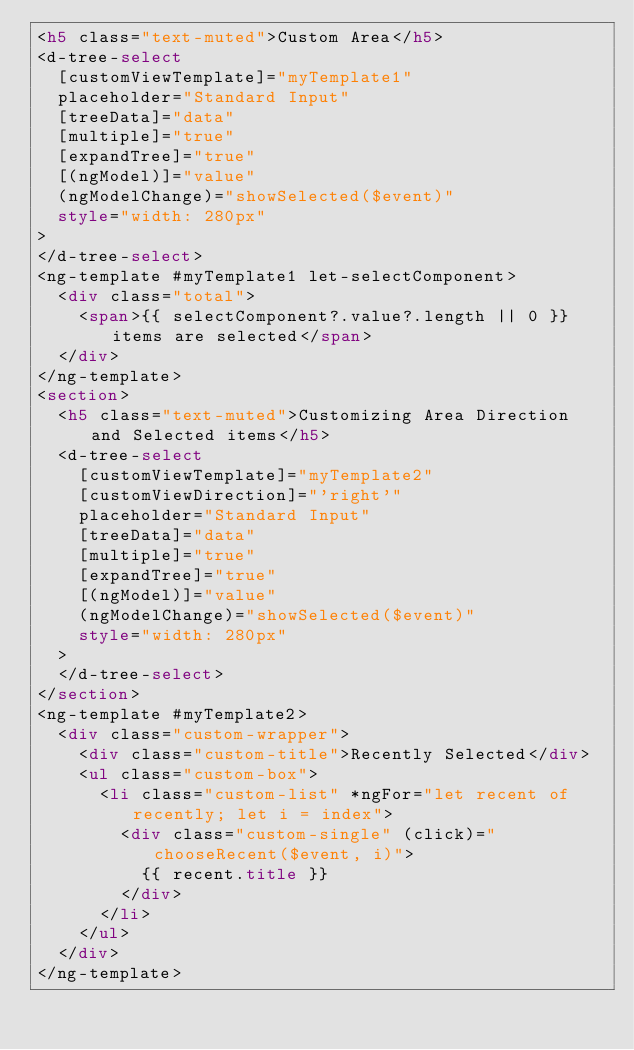<code> <loc_0><loc_0><loc_500><loc_500><_HTML_><h5 class="text-muted">Custom Area</h5>
<d-tree-select
  [customViewTemplate]="myTemplate1"
  placeholder="Standard Input"
  [treeData]="data"
  [multiple]="true"
  [expandTree]="true"
  [(ngModel)]="value"
  (ngModelChange)="showSelected($event)"
  style="width: 280px"
>
</d-tree-select>
<ng-template #myTemplate1 let-selectComponent>
  <div class="total">
    <span>{{ selectComponent?.value?.length || 0 }} items are selected</span>
  </div>
</ng-template>
<section>
  <h5 class="text-muted">Customizing Area Direction and Selected items</h5>
  <d-tree-select
    [customViewTemplate]="myTemplate2"
    [customViewDirection]="'right'"
    placeholder="Standard Input"
    [treeData]="data"
    [multiple]="true"
    [expandTree]="true"
    [(ngModel)]="value"
    (ngModelChange)="showSelected($event)"
    style="width: 280px"
  >
  </d-tree-select>
</section>
<ng-template #myTemplate2>
  <div class="custom-wrapper">
    <div class="custom-title">Recently Selected</div>
    <ul class="custom-box">
      <li class="custom-list" *ngFor="let recent of recently; let i = index">
        <div class="custom-single" (click)="chooseRecent($event, i)">
          {{ recent.title }}
        </div>
      </li>
    </ul>
  </div>
</ng-template>
</code> 